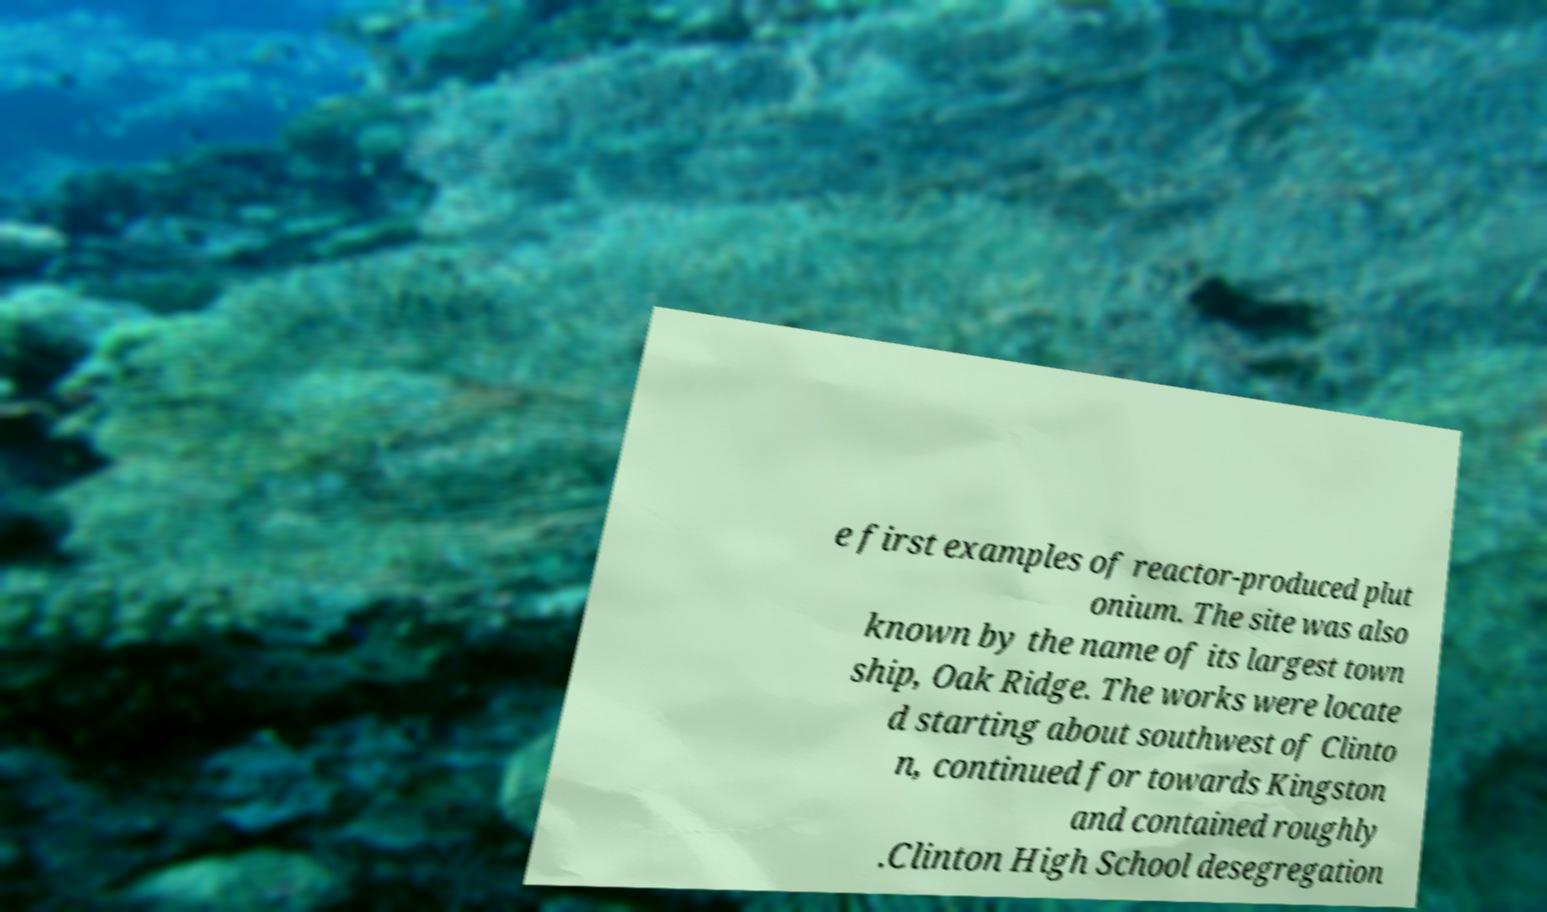I need the written content from this picture converted into text. Can you do that? e first examples of reactor-produced plut onium. The site was also known by the name of its largest town ship, Oak Ridge. The works were locate d starting about southwest of Clinto n, continued for towards Kingston and contained roughly .Clinton High School desegregation 